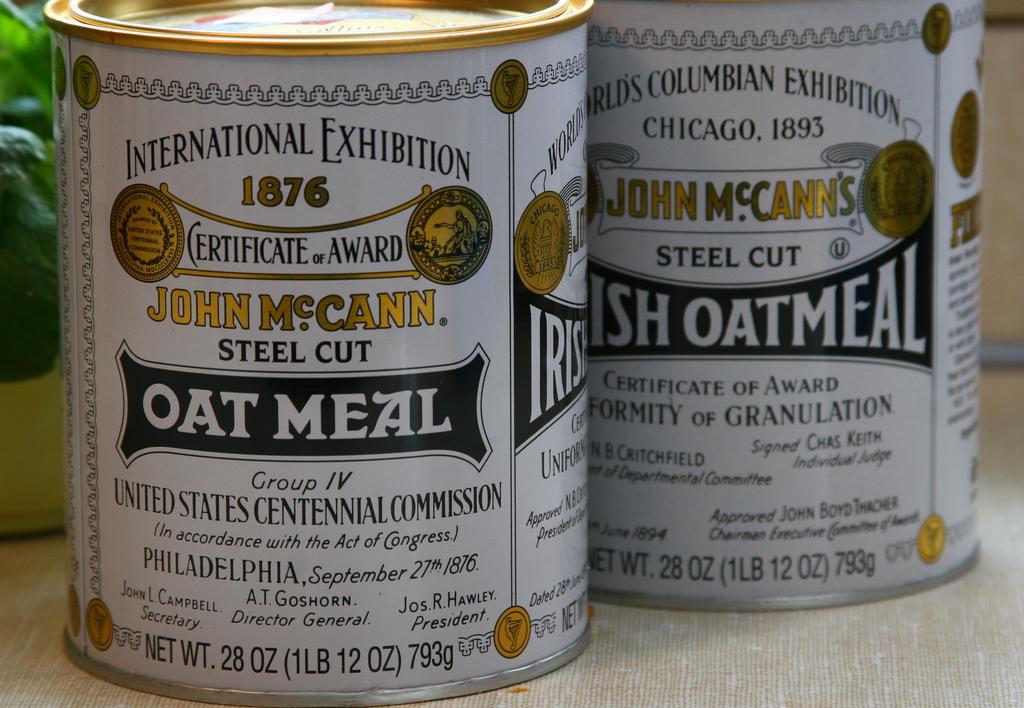What are the first two words, printed at the top of the label, of the can on the left?
Offer a very short reply. International exhibition. Whats the city on the cans?
Ensure brevity in your answer.  Philadelphia. 